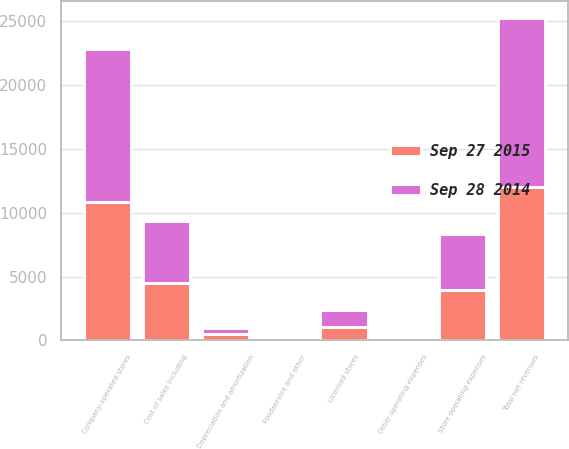<chart> <loc_0><loc_0><loc_500><loc_500><stacked_bar_chart><ecel><fcel>Company-operated stores<fcel>Licensed stores<fcel>Foodservice and other<fcel>Total net revenues<fcel>Cost of sales including<fcel>Store operating expenses<fcel>Other operating expenses<fcel>Depreciation and amortization<nl><fcel>Sep 28 2014<fcel>11925.6<fcel>1334.4<fcel>33.4<fcel>13293.4<fcel>4845<fcel>4387.9<fcel>122.8<fcel>522.3<nl><fcel>Sep 27 2015<fcel>10866.5<fcel>1074.9<fcel>39.1<fcel>11980.5<fcel>4487<fcel>3946.8<fcel>100.4<fcel>469.5<nl></chart> 